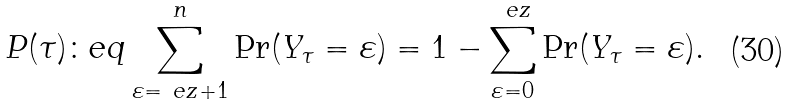Convert formula to latex. <formula><loc_0><loc_0><loc_500><loc_500>P ( \tau ) \colon e q \sum _ { \varepsilon = \ e z + 1 } ^ { n } \Pr ( Y _ { \tau } = \varepsilon ) = 1 - \sum _ { \varepsilon = 0 } ^ { \ e z } \Pr ( Y _ { \tau } = \varepsilon ) .</formula> 